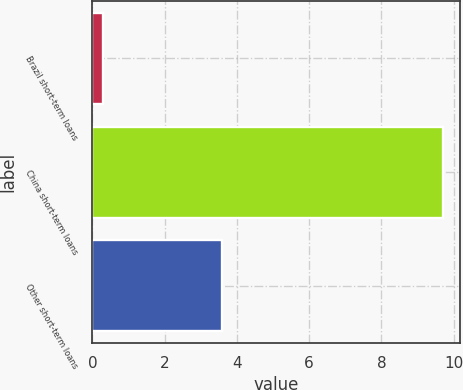Convert chart. <chart><loc_0><loc_0><loc_500><loc_500><bar_chart><fcel>Brazil short-term loans<fcel>China short-term loans<fcel>Other short-term loans<nl><fcel>0.3<fcel>9.7<fcel>3.6<nl></chart> 